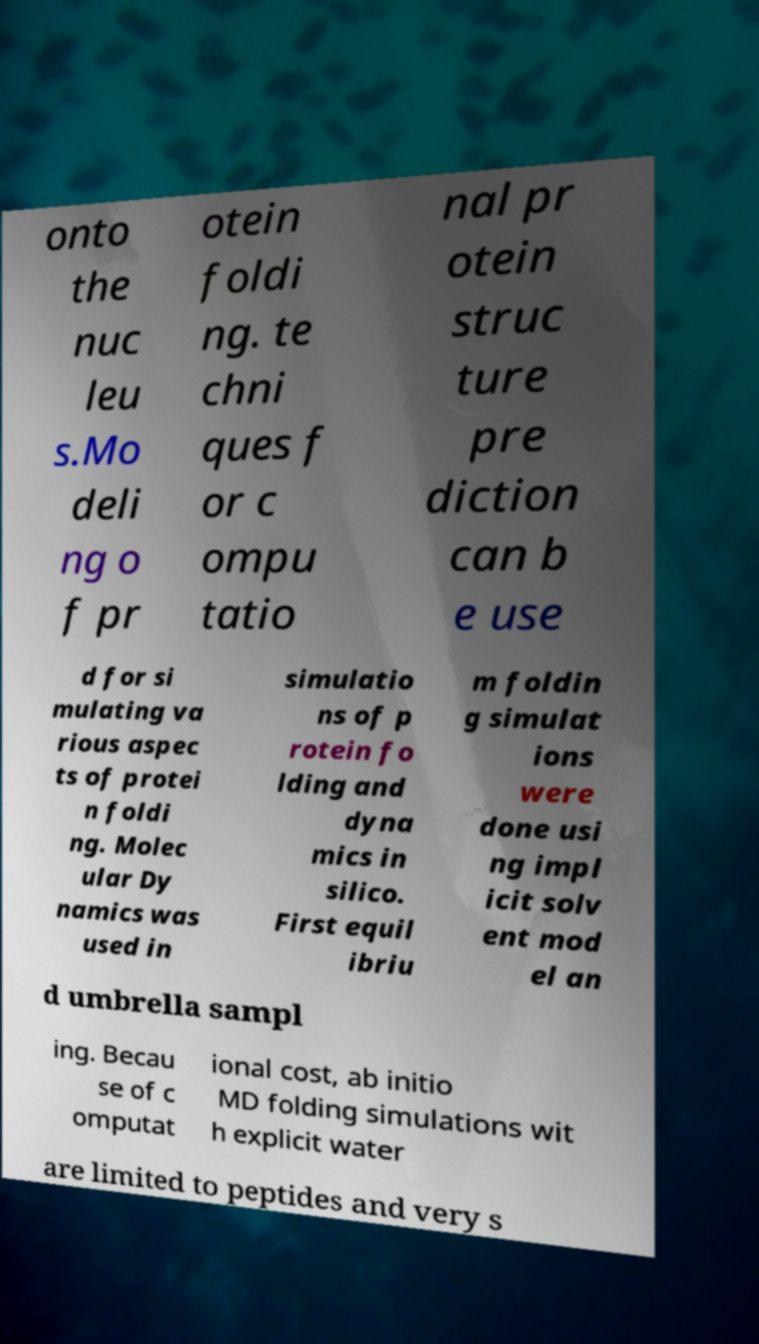For documentation purposes, I need the text within this image transcribed. Could you provide that? onto the nuc leu s.Mo deli ng o f pr otein foldi ng. te chni ques f or c ompu tatio nal pr otein struc ture pre diction can b e use d for si mulating va rious aspec ts of protei n foldi ng. Molec ular Dy namics was used in simulatio ns of p rotein fo lding and dyna mics in silico. First equil ibriu m foldin g simulat ions were done usi ng impl icit solv ent mod el an d umbrella sampl ing. Becau se of c omputat ional cost, ab initio MD folding simulations wit h explicit water are limited to peptides and very s 